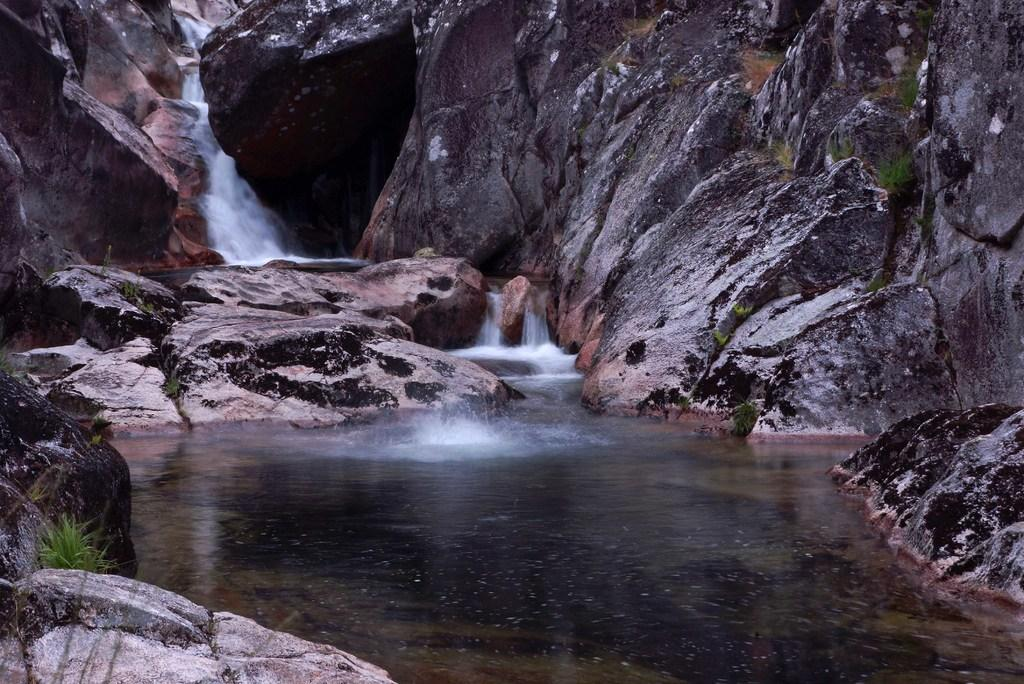What natural feature is the main subject of the image? There is a waterfall in the image. What can be seen in the background of the image? There are rocks in the background of the image. What is visible at the bottom of the image? Water and plants are present at the bottom of the image. What type of religion is practiced in the alley shown in the image? There is no alley present in the image, and therefore no religious practice can be observed. 